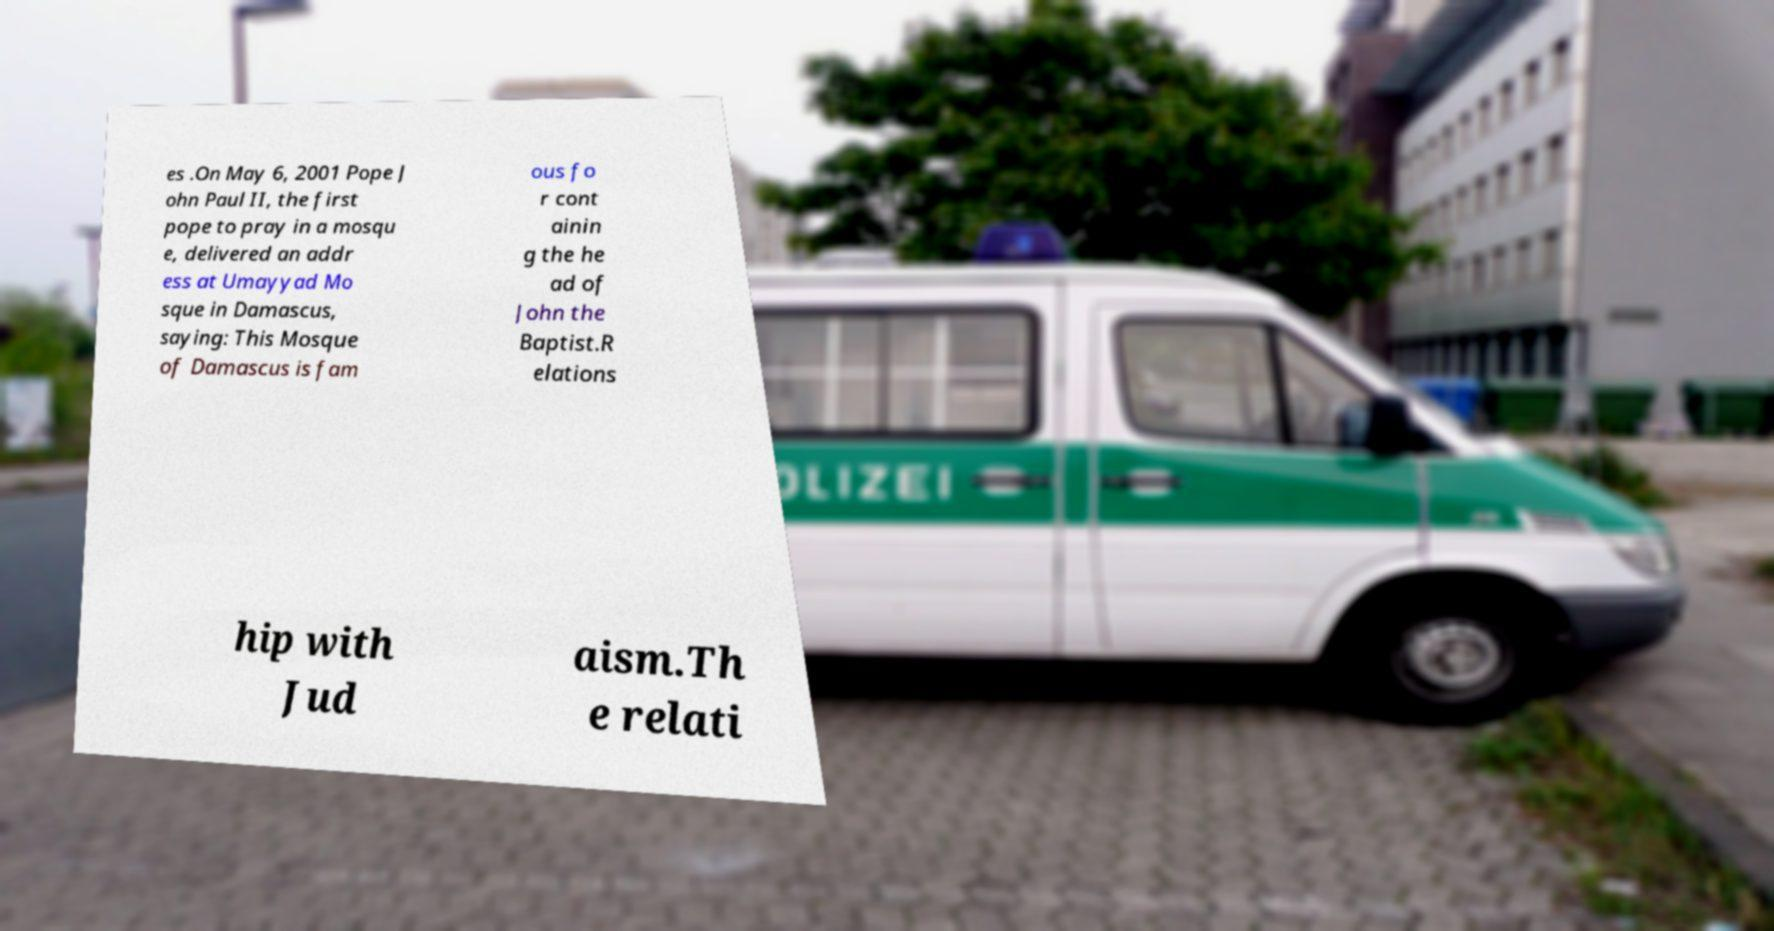Could you extract and type out the text from this image? es .On May 6, 2001 Pope J ohn Paul II, the first pope to pray in a mosqu e, delivered an addr ess at Umayyad Mo sque in Damascus, saying: This Mosque of Damascus is fam ous fo r cont ainin g the he ad of John the Baptist.R elations hip with Jud aism.Th e relati 